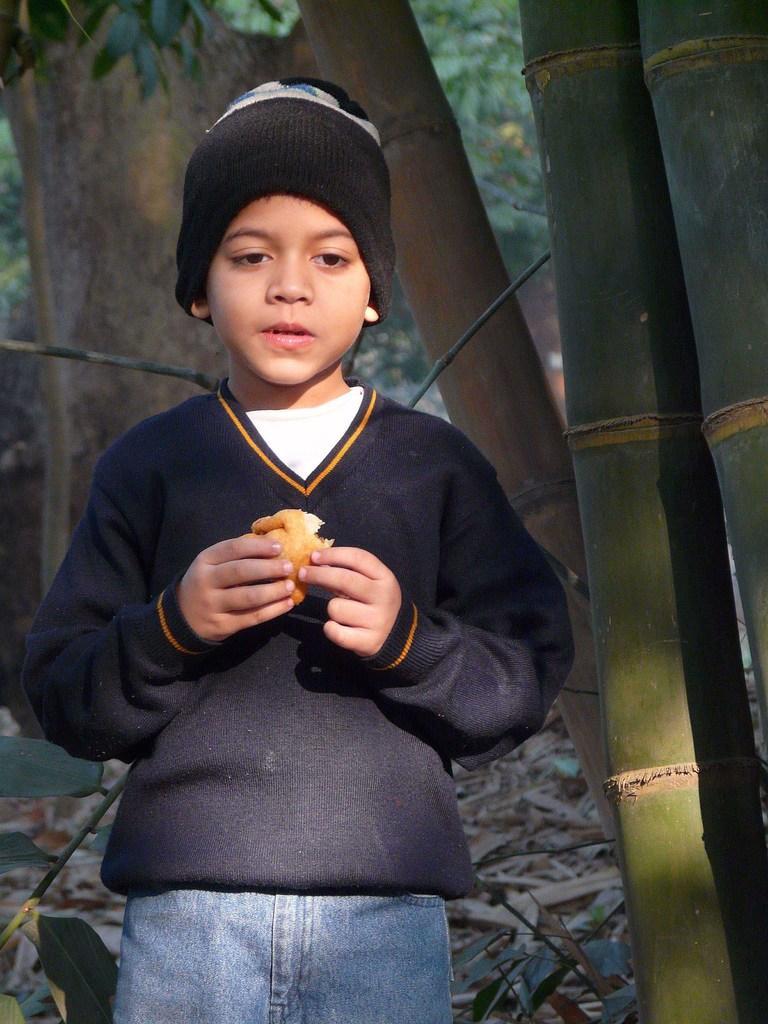How would you summarize this image in a sentence or two? In front of the image there is a boy holding the food item in his hand. Behind him there are trees. At the bottom of the image there are dried leaves on the surface. 